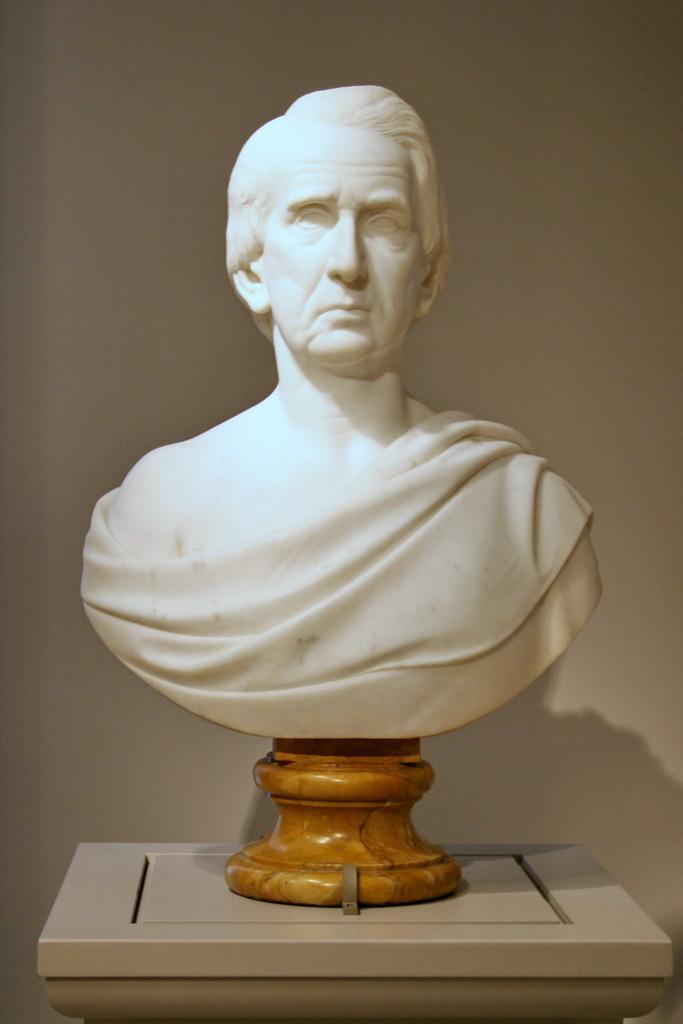What is the main subject of the image? There is a statue in the image. How is the statue positioned in the image? The statue is on a stand. What can be seen in the background of the image? There is a wall visible in the background of the image. How many cherries are on the statue in the image? There are no cherries present on the statue in the image. What type of bone can be seen in the statue's hand in the image? There is no bone present in the image, and the statue's hands do not hold any objects. 